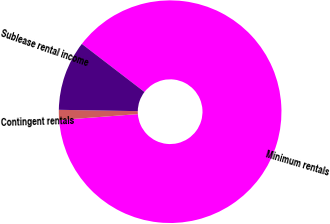Convert chart to OTSL. <chart><loc_0><loc_0><loc_500><loc_500><pie_chart><fcel>Minimum rentals<fcel>Contingent rentals<fcel>Sublease rental income<nl><fcel>88.39%<fcel>1.46%<fcel>10.15%<nl></chart> 